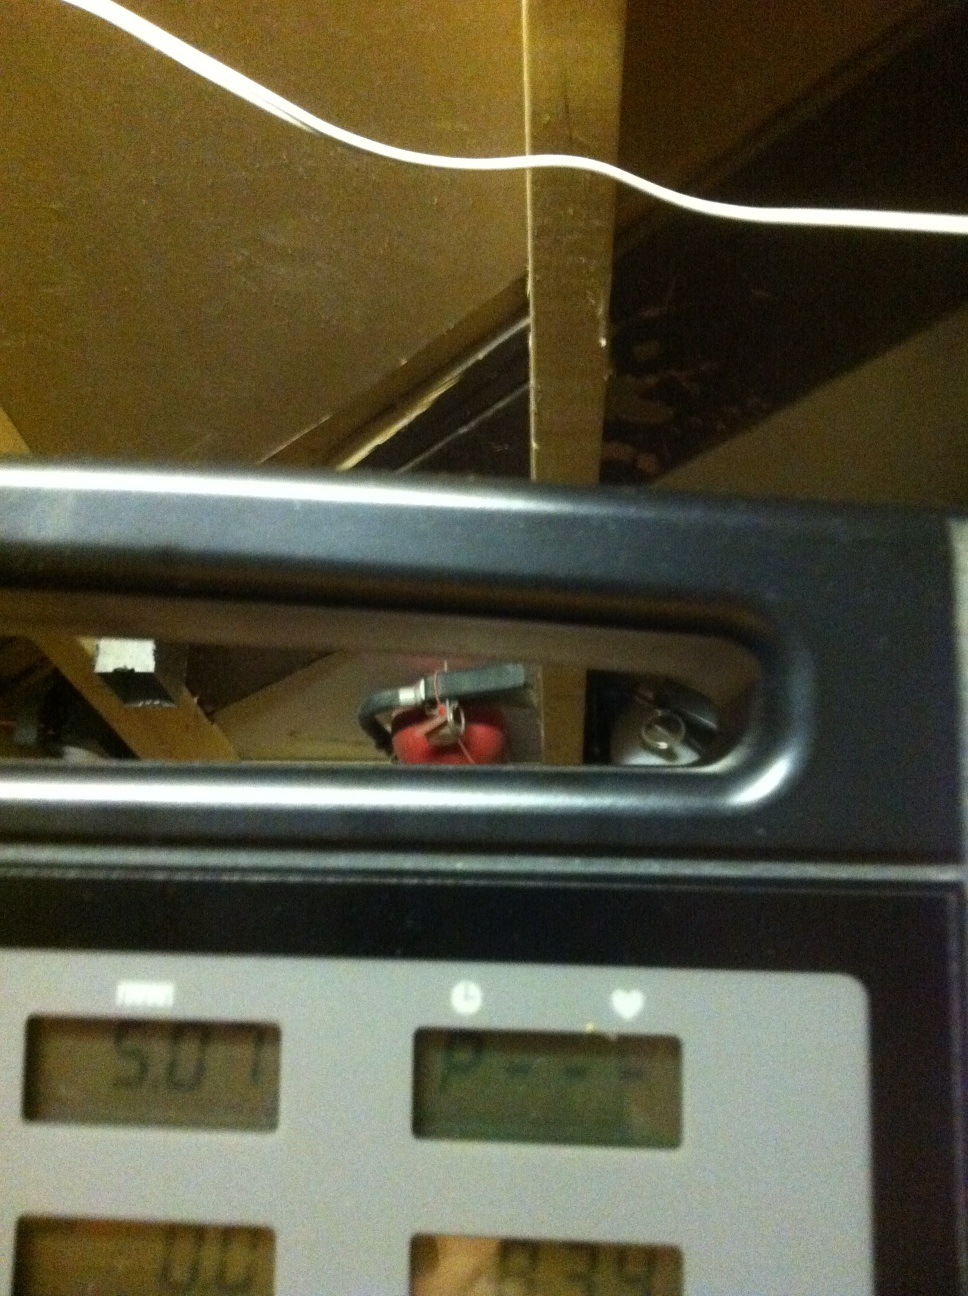Imagine this treadmill display is part of an advanced AI system that tracks more than just distance. What other metrics could it possibly track and display? Imagine this treadmill is integrated with an advanced AI system! Besides distance, it could track metrics such as pace, cadence, calories burned, aerobic levels, hydration levels, step count, elevation gain, muscle fatigue, real-time metabolic rate, heart rate variability, and even stress levels. This would provide a comprehensive fitness profile, helping you optimize your workouts in a way that suits your health and fitness goals precisely. 